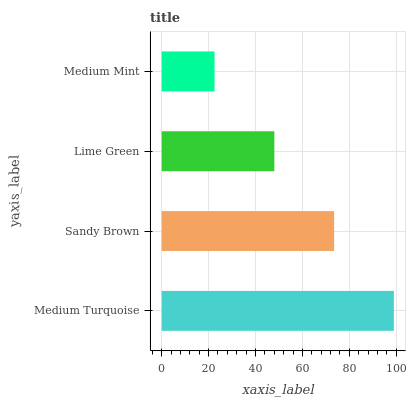Is Medium Mint the minimum?
Answer yes or no. Yes. Is Medium Turquoise the maximum?
Answer yes or no. Yes. Is Sandy Brown the minimum?
Answer yes or no. No. Is Sandy Brown the maximum?
Answer yes or no. No. Is Medium Turquoise greater than Sandy Brown?
Answer yes or no. Yes. Is Sandy Brown less than Medium Turquoise?
Answer yes or no. Yes. Is Sandy Brown greater than Medium Turquoise?
Answer yes or no. No. Is Medium Turquoise less than Sandy Brown?
Answer yes or no. No. Is Sandy Brown the high median?
Answer yes or no. Yes. Is Lime Green the low median?
Answer yes or no. Yes. Is Medium Turquoise the high median?
Answer yes or no. No. Is Medium Turquoise the low median?
Answer yes or no. No. 